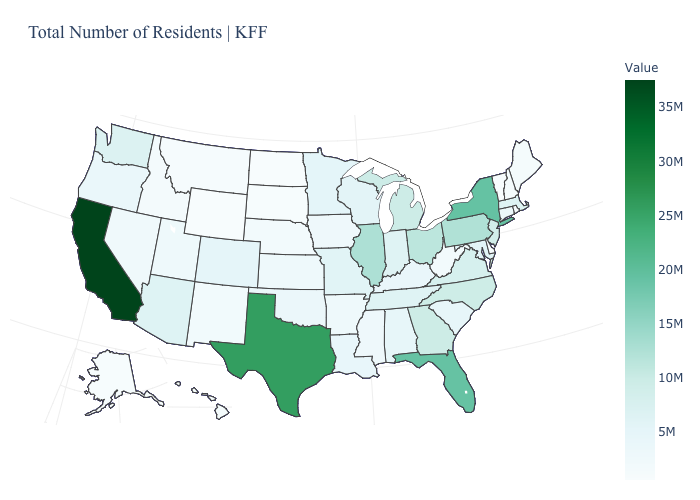Does the map have missing data?
Give a very brief answer. No. Among the states that border Pennsylvania , which have the lowest value?
Quick response, please. Delaware. Does Delaware have a lower value than Minnesota?
Quick response, please. Yes. Which states hav the highest value in the West?
Keep it brief. California. Does Idaho have a higher value than Michigan?
Give a very brief answer. No. Among the states that border Pennsylvania , does Ohio have the lowest value?
Keep it brief. No. Which states have the highest value in the USA?
Be succinct. California. Does the map have missing data?
Keep it brief. No. 